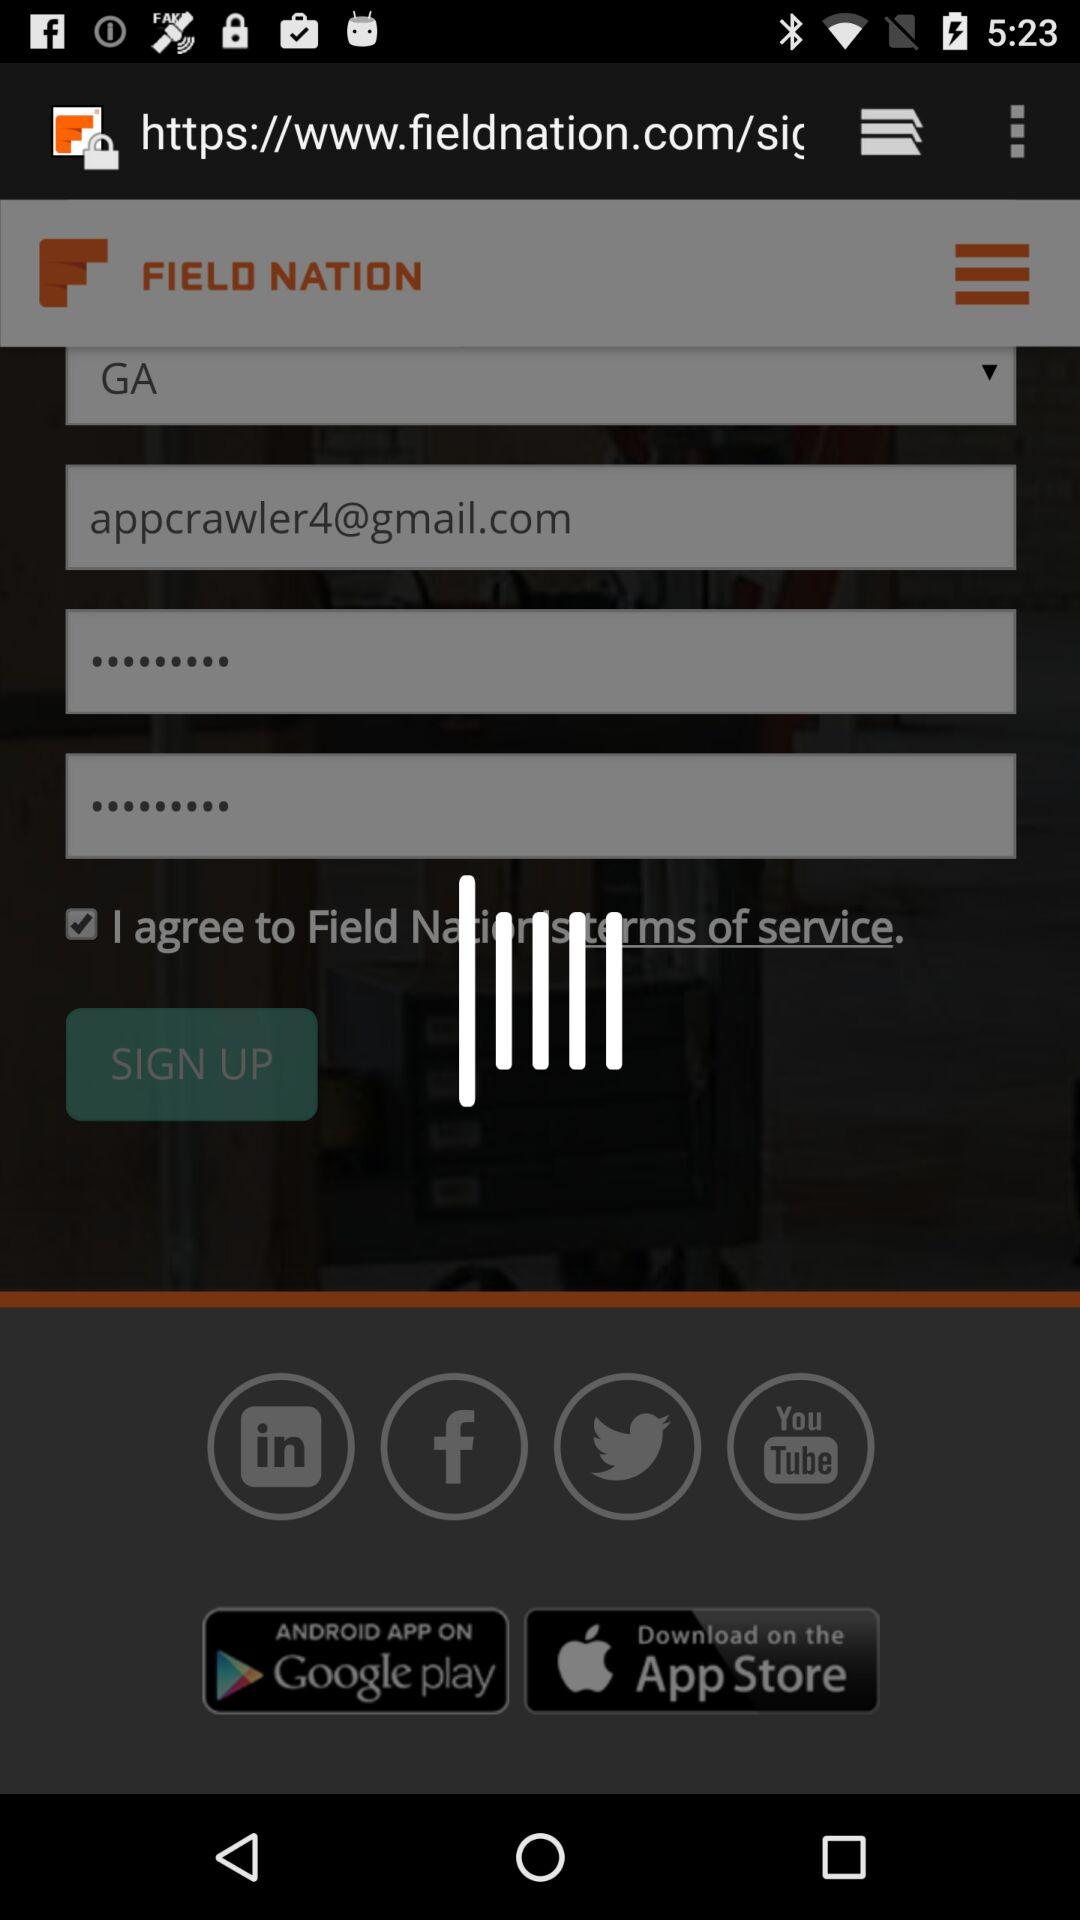What is the email address? The email address is appcrawler4@gmail.com. 